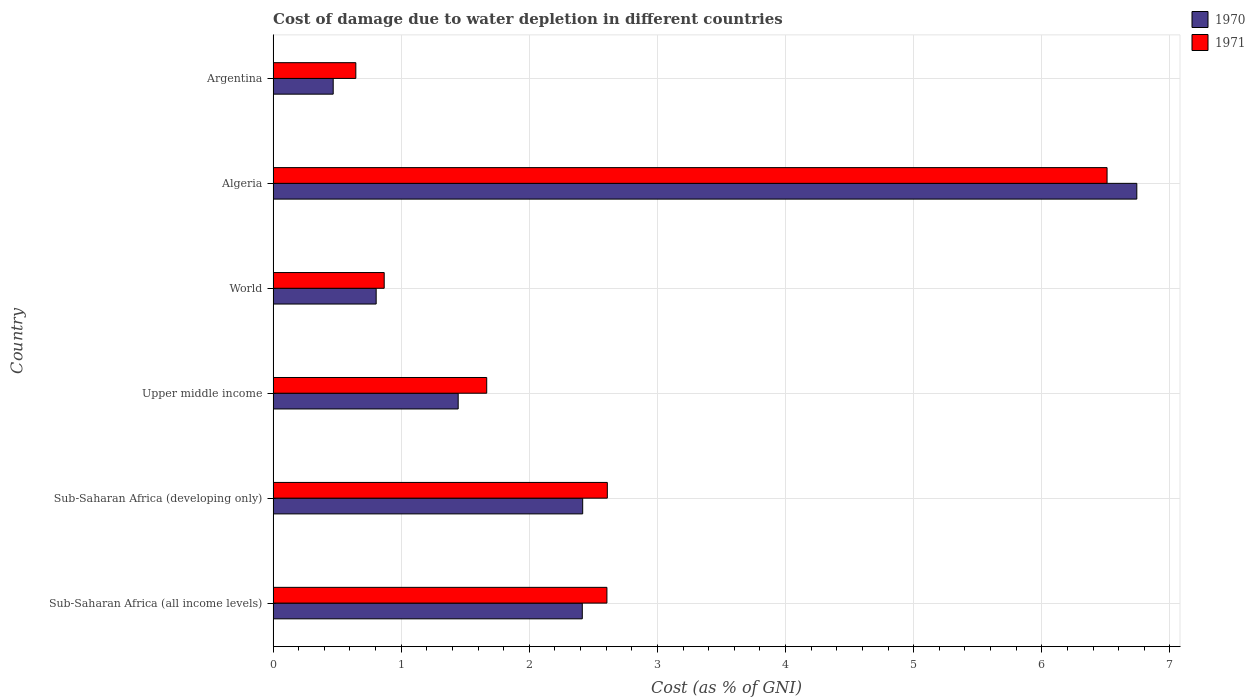Are the number of bars on each tick of the Y-axis equal?
Offer a very short reply. Yes. How many bars are there on the 5th tick from the bottom?
Provide a short and direct response. 2. What is the label of the 3rd group of bars from the top?
Your answer should be very brief. World. What is the cost of damage caused due to water depletion in 1970 in Algeria?
Provide a short and direct response. 6.74. Across all countries, what is the maximum cost of damage caused due to water depletion in 1970?
Your answer should be compact. 6.74. Across all countries, what is the minimum cost of damage caused due to water depletion in 1971?
Your response must be concise. 0.65. In which country was the cost of damage caused due to water depletion in 1971 maximum?
Provide a succinct answer. Algeria. In which country was the cost of damage caused due to water depletion in 1971 minimum?
Your answer should be compact. Argentina. What is the total cost of damage caused due to water depletion in 1971 in the graph?
Provide a succinct answer. 14.9. What is the difference between the cost of damage caused due to water depletion in 1970 in Algeria and that in World?
Your answer should be compact. 5.94. What is the difference between the cost of damage caused due to water depletion in 1971 in Sub-Saharan Africa (all income levels) and the cost of damage caused due to water depletion in 1970 in Algeria?
Provide a short and direct response. -4.14. What is the average cost of damage caused due to water depletion in 1970 per country?
Your response must be concise. 2.38. What is the difference between the cost of damage caused due to water depletion in 1971 and cost of damage caused due to water depletion in 1970 in Sub-Saharan Africa (all income levels)?
Provide a succinct answer. 0.19. What is the ratio of the cost of damage caused due to water depletion in 1971 in Sub-Saharan Africa (all income levels) to that in Upper middle income?
Ensure brevity in your answer.  1.56. Is the difference between the cost of damage caused due to water depletion in 1971 in Sub-Saharan Africa (developing only) and World greater than the difference between the cost of damage caused due to water depletion in 1970 in Sub-Saharan Africa (developing only) and World?
Your answer should be very brief. Yes. What is the difference between the highest and the second highest cost of damage caused due to water depletion in 1970?
Provide a short and direct response. 4.33. What is the difference between the highest and the lowest cost of damage caused due to water depletion in 1971?
Keep it short and to the point. 5.86. In how many countries, is the cost of damage caused due to water depletion in 1970 greater than the average cost of damage caused due to water depletion in 1970 taken over all countries?
Offer a very short reply. 3. What does the 2nd bar from the top in Sub-Saharan Africa (developing only) represents?
Your answer should be compact. 1970. What does the 2nd bar from the bottom in Algeria represents?
Provide a short and direct response. 1971. Are all the bars in the graph horizontal?
Your response must be concise. Yes. How many countries are there in the graph?
Your response must be concise. 6. Are the values on the major ticks of X-axis written in scientific E-notation?
Ensure brevity in your answer.  No. Does the graph contain grids?
Your response must be concise. Yes. How many legend labels are there?
Provide a succinct answer. 2. What is the title of the graph?
Provide a short and direct response. Cost of damage due to water depletion in different countries. What is the label or title of the X-axis?
Offer a terse response. Cost (as % of GNI). What is the Cost (as % of GNI) in 1970 in Sub-Saharan Africa (all income levels)?
Your answer should be very brief. 2.41. What is the Cost (as % of GNI) of 1971 in Sub-Saharan Africa (all income levels)?
Provide a short and direct response. 2.61. What is the Cost (as % of GNI) of 1970 in Sub-Saharan Africa (developing only)?
Offer a terse response. 2.42. What is the Cost (as % of GNI) in 1971 in Sub-Saharan Africa (developing only)?
Your response must be concise. 2.61. What is the Cost (as % of GNI) of 1970 in Upper middle income?
Offer a very short reply. 1.44. What is the Cost (as % of GNI) in 1971 in Upper middle income?
Your response must be concise. 1.67. What is the Cost (as % of GNI) of 1970 in World?
Offer a terse response. 0.8. What is the Cost (as % of GNI) in 1971 in World?
Your response must be concise. 0.87. What is the Cost (as % of GNI) in 1970 in Algeria?
Your answer should be very brief. 6.74. What is the Cost (as % of GNI) of 1971 in Algeria?
Give a very brief answer. 6.51. What is the Cost (as % of GNI) in 1970 in Argentina?
Provide a short and direct response. 0.47. What is the Cost (as % of GNI) of 1971 in Argentina?
Make the answer very short. 0.65. Across all countries, what is the maximum Cost (as % of GNI) in 1970?
Keep it short and to the point. 6.74. Across all countries, what is the maximum Cost (as % of GNI) in 1971?
Offer a very short reply. 6.51. Across all countries, what is the minimum Cost (as % of GNI) of 1970?
Your response must be concise. 0.47. Across all countries, what is the minimum Cost (as % of GNI) in 1971?
Offer a terse response. 0.65. What is the total Cost (as % of GNI) of 1970 in the graph?
Ensure brevity in your answer.  14.29. What is the total Cost (as % of GNI) in 1971 in the graph?
Give a very brief answer. 14.9. What is the difference between the Cost (as % of GNI) of 1970 in Sub-Saharan Africa (all income levels) and that in Sub-Saharan Africa (developing only)?
Provide a short and direct response. -0. What is the difference between the Cost (as % of GNI) in 1971 in Sub-Saharan Africa (all income levels) and that in Sub-Saharan Africa (developing only)?
Make the answer very short. -0. What is the difference between the Cost (as % of GNI) in 1970 in Sub-Saharan Africa (all income levels) and that in Upper middle income?
Offer a very short reply. 0.97. What is the difference between the Cost (as % of GNI) in 1971 in Sub-Saharan Africa (all income levels) and that in Upper middle income?
Your answer should be compact. 0.94. What is the difference between the Cost (as % of GNI) of 1970 in Sub-Saharan Africa (all income levels) and that in World?
Offer a very short reply. 1.61. What is the difference between the Cost (as % of GNI) of 1971 in Sub-Saharan Africa (all income levels) and that in World?
Offer a very short reply. 1.74. What is the difference between the Cost (as % of GNI) of 1970 in Sub-Saharan Africa (all income levels) and that in Algeria?
Keep it short and to the point. -4.33. What is the difference between the Cost (as % of GNI) in 1971 in Sub-Saharan Africa (all income levels) and that in Algeria?
Offer a very short reply. -3.9. What is the difference between the Cost (as % of GNI) of 1970 in Sub-Saharan Africa (all income levels) and that in Argentina?
Keep it short and to the point. 1.94. What is the difference between the Cost (as % of GNI) of 1971 in Sub-Saharan Africa (all income levels) and that in Argentina?
Your answer should be very brief. 1.96. What is the difference between the Cost (as % of GNI) of 1970 in Sub-Saharan Africa (developing only) and that in Upper middle income?
Give a very brief answer. 0.97. What is the difference between the Cost (as % of GNI) of 1971 in Sub-Saharan Africa (developing only) and that in Upper middle income?
Make the answer very short. 0.94. What is the difference between the Cost (as % of GNI) in 1970 in Sub-Saharan Africa (developing only) and that in World?
Give a very brief answer. 1.61. What is the difference between the Cost (as % of GNI) in 1971 in Sub-Saharan Africa (developing only) and that in World?
Offer a very short reply. 1.74. What is the difference between the Cost (as % of GNI) in 1970 in Sub-Saharan Africa (developing only) and that in Algeria?
Your answer should be very brief. -4.33. What is the difference between the Cost (as % of GNI) of 1971 in Sub-Saharan Africa (developing only) and that in Algeria?
Provide a succinct answer. -3.9. What is the difference between the Cost (as % of GNI) in 1970 in Sub-Saharan Africa (developing only) and that in Argentina?
Your answer should be compact. 1.95. What is the difference between the Cost (as % of GNI) in 1971 in Sub-Saharan Africa (developing only) and that in Argentina?
Ensure brevity in your answer.  1.96. What is the difference between the Cost (as % of GNI) of 1970 in Upper middle income and that in World?
Your answer should be compact. 0.64. What is the difference between the Cost (as % of GNI) of 1971 in Upper middle income and that in World?
Provide a succinct answer. 0.8. What is the difference between the Cost (as % of GNI) in 1970 in Upper middle income and that in Algeria?
Provide a short and direct response. -5.3. What is the difference between the Cost (as % of GNI) in 1971 in Upper middle income and that in Algeria?
Provide a succinct answer. -4.84. What is the difference between the Cost (as % of GNI) in 1970 in Upper middle income and that in Argentina?
Keep it short and to the point. 0.98. What is the difference between the Cost (as % of GNI) of 1971 in Upper middle income and that in Argentina?
Keep it short and to the point. 1.02. What is the difference between the Cost (as % of GNI) of 1970 in World and that in Algeria?
Your response must be concise. -5.94. What is the difference between the Cost (as % of GNI) in 1971 in World and that in Algeria?
Ensure brevity in your answer.  -5.64. What is the difference between the Cost (as % of GNI) in 1970 in World and that in Argentina?
Provide a succinct answer. 0.34. What is the difference between the Cost (as % of GNI) of 1971 in World and that in Argentina?
Give a very brief answer. 0.22. What is the difference between the Cost (as % of GNI) of 1970 in Algeria and that in Argentina?
Provide a short and direct response. 6.27. What is the difference between the Cost (as % of GNI) in 1971 in Algeria and that in Argentina?
Provide a succinct answer. 5.86. What is the difference between the Cost (as % of GNI) in 1970 in Sub-Saharan Africa (all income levels) and the Cost (as % of GNI) in 1971 in Sub-Saharan Africa (developing only)?
Your answer should be compact. -0.2. What is the difference between the Cost (as % of GNI) of 1970 in Sub-Saharan Africa (all income levels) and the Cost (as % of GNI) of 1971 in Upper middle income?
Your answer should be very brief. 0.75. What is the difference between the Cost (as % of GNI) of 1970 in Sub-Saharan Africa (all income levels) and the Cost (as % of GNI) of 1971 in World?
Make the answer very short. 1.55. What is the difference between the Cost (as % of GNI) in 1970 in Sub-Saharan Africa (all income levels) and the Cost (as % of GNI) in 1971 in Algeria?
Your response must be concise. -4.1. What is the difference between the Cost (as % of GNI) in 1970 in Sub-Saharan Africa (all income levels) and the Cost (as % of GNI) in 1971 in Argentina?
Make the answer very short. 1.77. What is the difference between the Cost (as % of GNI) of 1970 in Sub-Saharan Africa (developing only) and the Cost (as % of GNI) of 1971 in Upper middle income?
Make the answer very short. 0.75. What is the difference between the Cost (as % of GNI) in 1970 in Sub-Saharan Africa (developing only) and the Cost (as % of GNI) in 1971 in World?
Your response must be concise. 1.55. What is the difference between the Cost (as % of GNI) in 1970 in Sub-Saharan Africa (developing only) and the Cost (as % of GNI) in 1971 in Algeria?
Provide a short and direct response. -4.09. What is the difference between the Cost (as % of GNI) of 1970 in Sub-Saharan Africa (developing only) and the Cost (as % of GNI) of 1971 in Argentina?
Keep it short and to the point. 1.77. What is the difference between the Cost (as % of GNI) of 1970 in Upper middle income and the Cost (as % of GNI) of 1971 in World?
Provide a short and direct response. 0.58. What is the difference between the Cost (as % of GNI) of 1970 in Upper middle income and the Cost (as % of GNI) of 1971 in Algeria?
Your answer should be compact. -5.07. What is the difference between the Cost (as % of GNI) in 1970 in Upper middle income and the Cost (as % of GNI) in 1971 in Argentina?
Make the answer very short. 0.8. What is the difference between the Cost (as % of GNI) in 1970 in World and the Cost (as % of GNI) in 1971 in Algeria?
Keep it short and to the point. -5.71. What is the difference between the Cost (as % of GNI) in 1970 in World and the Cost (as % of GNI) in 1971 in Argentina?
Provide a succinct answer. 0.16. What is the difference between the Cost (as % of GNI) in 1970 in Algeria and the Cost (as % of GNI) in 1971 in Argentina?
Make the answer very short. 6.1. What is the average Cost (as % of GNI) of 1970 per country?
Make the answer very short. 2.38. What is the average Cost (as % of GNI) in 1971 per country?
Make the answer very short. 2.48. What is the difference between the Cost (as % of GNI) of 1970 and Cost (as % of GNI) of 1971 in Sub-Saharan Africa (all income levels)?
Ensure brevity in your answer.  -0.19. What is the difference between the Cost (as % of GNI) of 1970 and Cost (as % of GNI) of 1971 in Sub-Saharan Africa (developing only)?
Offer a very short reply. -0.19. What is the difference between the Cost (as % of GNI) in 1970 and Cost (as % of GNI) in 1971 in Upper middle income?
Your answer should be very brief. -0.22. What is the difference between the Cost (as % of GNI) in 1970 and Cost (as % of GNI) in 1971 in World?
Ensure brevity in your answer.  -0.06. What is the difference between the Cost (as % of GNI) in 1970 and Cost (as % of GNI) in 1971 in Algeria?
Your answer should be compact. 0.23. What is the difference between the Cost (as % of GNI) of 1970 and Cost (as % of GNI) of 1971 in Argentina?
Give a very brief answer. -0.18. What is the ratio of the Cost (as % of GNI) of 1970 in Sub-Saharan Africa (all income levels) to that in Upper middle income?
Give a very brief answer. 1.67. What is the ratio of the Cost (as % of GNI) in 1971 in Sub-Saharan Africa (all income levels) to that in Upper middle income?
Offer a very short reply. 1.56. What is the ratio of the Cost (as % of GNI) of 1970 in Sub-Saharan Africa (all income levels) to that in World?
Ensure brevity in your answer.  3. What is the ratio of the Cost (as % of GNI) of 1971 in Sub-Saharan Africa (all income levels) to that in World?
Your response must be concise. 3. What is the ratio of the Cost (as % of GNI) in 1970 in Sub-Saharan Africa (all income levels) to that in Algeria?
Give a very brief answer. 0.36. What is the ratio of the Cost (as % of GNI) in 1971 in Sub-Saharan Africa (all income levels) to that in Algeria?
Offer a very short reply. 0.4. What is the ratio of the Cost (as % of GNI) of 1970 in Sub-Saharan Africa (all income levels) to that in Argentina?
Provide a short and direct response. 5.15. What is the ratio of the Cost (as % of GNI) of 1971 in Sub-Saharan Africa (all income levels) to that in Argentina?
Your response must be concise. 4.04. What is the ratio of the Cost (as % of GNI) of 1970 in Sub-Saharan Africa (developing only) to that in Upper middle income?
Make the answer very short. 1.67. What is the ratio of the Cost (as % of GNI) in 1971 in Sub-Saharan Africa (developing only) to that in Upper middle income?
Provide a short and direct response. 1.56. What is the ratio of the Cost (as % of GNI) of 1970 in Sub-Saharan Africa (developing only) to that in World?
Make the answer very short. 3. What is the ratio of the Cost (as % of GNI) in 1971 in Sub-Saharan Africa (developing only) to that in World?
Give a very brief answer. 3.01. What is the ratio of the Cost (as % of GNI) of 1970 in Sub-Saharan Africa (developing only) to that in Algeria?
Offer a terse response. 0.36. What is the ratio of the Cost (as % of GNI) in 1971 in Sub-Saharan Africa (developing only) to that in Algeria?
Your answer should be very brief. 0.4. What is the ratio of the Cost (as % of GNI) in 1970 in Sub-Saharan Africa (developing only) to that in Argentina?
Your response must be concise. 5.15. What is the ratio of the Cost (as % of GNI) in 1971 in Sub-Saharan Africa (developing only) to that in Argentina?
Offer a very short reply. 4.04. What is the ratio of the Cost (as % of GNI) of 1970 in Upper middle income to that in World?
Offer a terse response. 1.8. What is the ratio of the Cost (as % of GNI) in 1971 in Upper middle income to that in World?
Offer a terse response. 1.92. What is the ratio of the Cost (as % of GNI) of 1970 in Upper middle income to that in Algeria?
Your answer should be very brief. 0.21. What is the ratio of the Cost (as % of GNI) in 1971 in Upper middle income to that in Algeria?
Your answer should be very brief. 0.26. What is the ratio of the Cost (as % of GNI) of 1970 in Upper middle income to that in Argentina?
Offer a very short reply. 3.08. What is the ratio of the Cost (as % of GNI) of 1971 in Upper middle income to that in Argentina?
Offer a very short reply. 2.58. What is the ratio of the Cost (as % of GNI) of 1970 in World to that in Algeria?
Provide a short and direct response. 0.12. What is the ratio of the Cost (as % of GNI) in 1971 in World to that in Algeria?
Offer a terse response. 0.13. What is the ratio of the Cost (as % of GNI) of 1970 in World to that in Argentina?
Ensure brevity in your answer.  1.72. What is the ratio of the Cost (as % of GNI) of 1971 in World to that in Argentina?
Your answer should be very brief. 1.34. What is the ratio of the Cost (as % of GNI) in 1970 in Algeria to that in Argentina?
Make the answer very short. 14.38. What is the ratio of the Cost (as % of GNI) in 1971 in Algeria to that in Argentina?
Provide a short and direct response. 10.08. What is the difference between the highest and the second highest Cost (as % of GNI) of 1970?
Offer a very short reply. 4.33. What is the difference between the highest and the second highest Cost (as % of GNI) in 1971?
Keep it short and to the point. 3.9. What is the difference between the highest and the lowest Cost (as % of GNI) of 1970?
Your answer should be very brief. 6.27. What is the difference between the highest and the lowest Cost (as % of GNI) of 1971?
Make the answer very short. 5.86. 